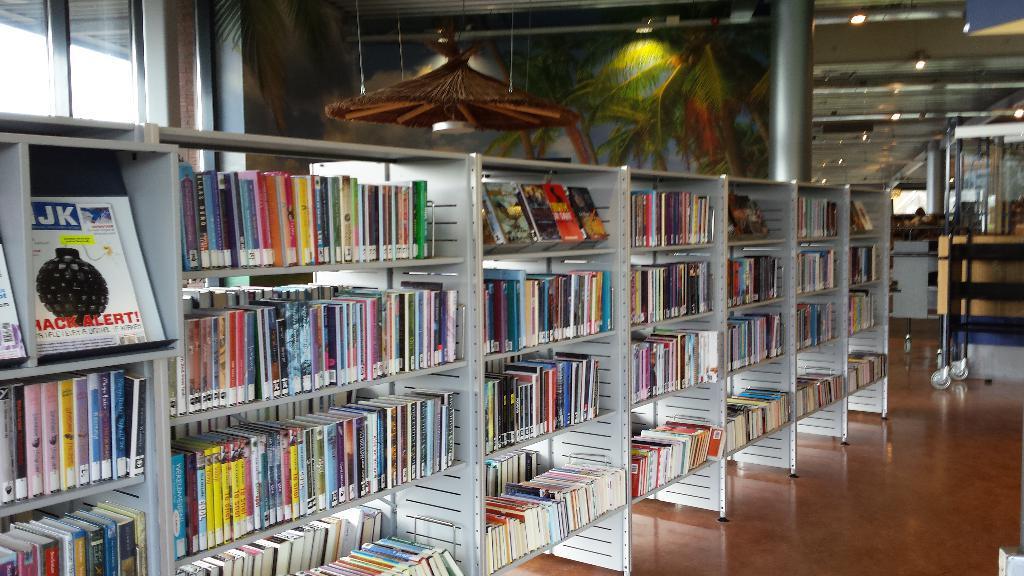Please provide a concise description of this image. In this image we can see the inner view of a building and we can see some bookshelves with the books and there are some lights attached to the ceiling and we can see some other objects in the room. 